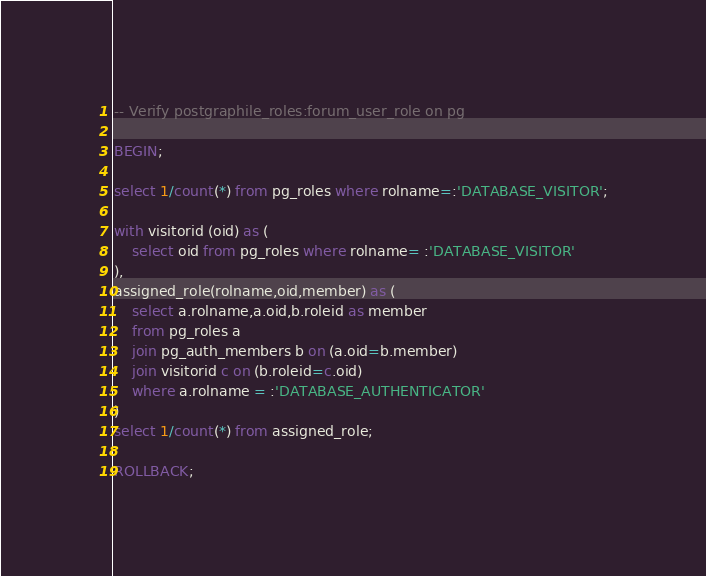<code> <loc_0><loc_0><loc_500><loc_500><_SQL_>-- Verify postgraphile_roles:forum_user_role on pg

BEGIN;

select 1/count(*) from pg_roles where rolname=:'DATABASE_VISITOR';

with visitorid (oid) as (
    select oid from pg_roles where rolname= :'DATABASE_VISITOR'
),
assigned_role(rolname,oid,member) as (
    select a.rolname,a.oid,b.roleid as member
    from pg_roles a
    join pg_auth_members b on (a.oid=b.member)
    join visitorid c on (b.roleid=c.oid)
    where a.rolname = :'DATABASE_AUTHENTICATOR'
)
select 1/count(*) from assigned_role;

ROLLBACK;
</code> 